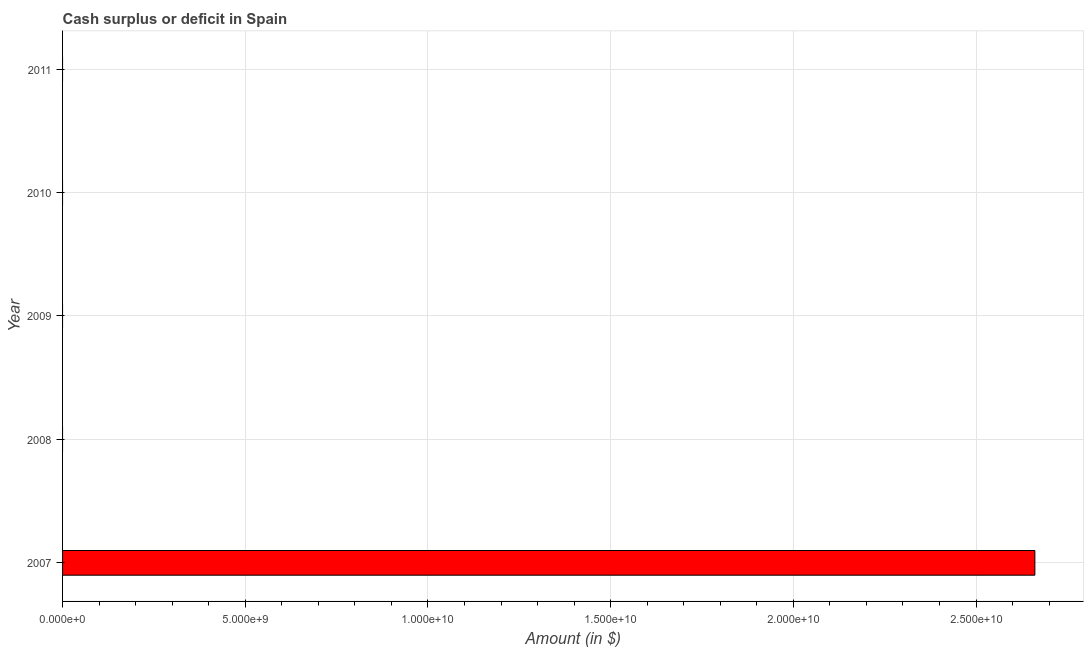What is the title of the graph?
Give a very brief answer. Cash surplus or deficit in Spain. What is the label or title of the X-axis?
Offer a very short reply. Amount (in $). What is the label or title of the Y-axis?
Offer a terse response. Year. Across all years, what is the maximum cash surplus or deficit?
Ensure brevity in your answer.  2.66e+1. Across all years, what is the minimum cash surplus or deficit?
Provide a short and direct response. 0. What is the sum of the cash surplus or deficit?
Offer a terse response. 2.66e+1. What is the average cash surplus or deficit per year?
Your answer should be very brief. 5.32e+09. What is the difference between the highest and the lowest cash surplus or deficit?
Offer a terse response. 2.66e+1. In how many years, is the cash surplus or deficit greater than the average cash surplus or deficit taken over all years?
Your answer should be very brief. 1. Are all the bars in the graph horizontal?
Your response must be concise. Yes. How many years are there in the graph?
Give a very brief answer. 5. What is the Amount (in $) in 2007?
Offer a terse response. 2.66e+1. What is the Amount (in $) in 2009?
Your answer should be compact. 0. What is the Amount (in $) of 2011?
Give a very brief answer. 0. 